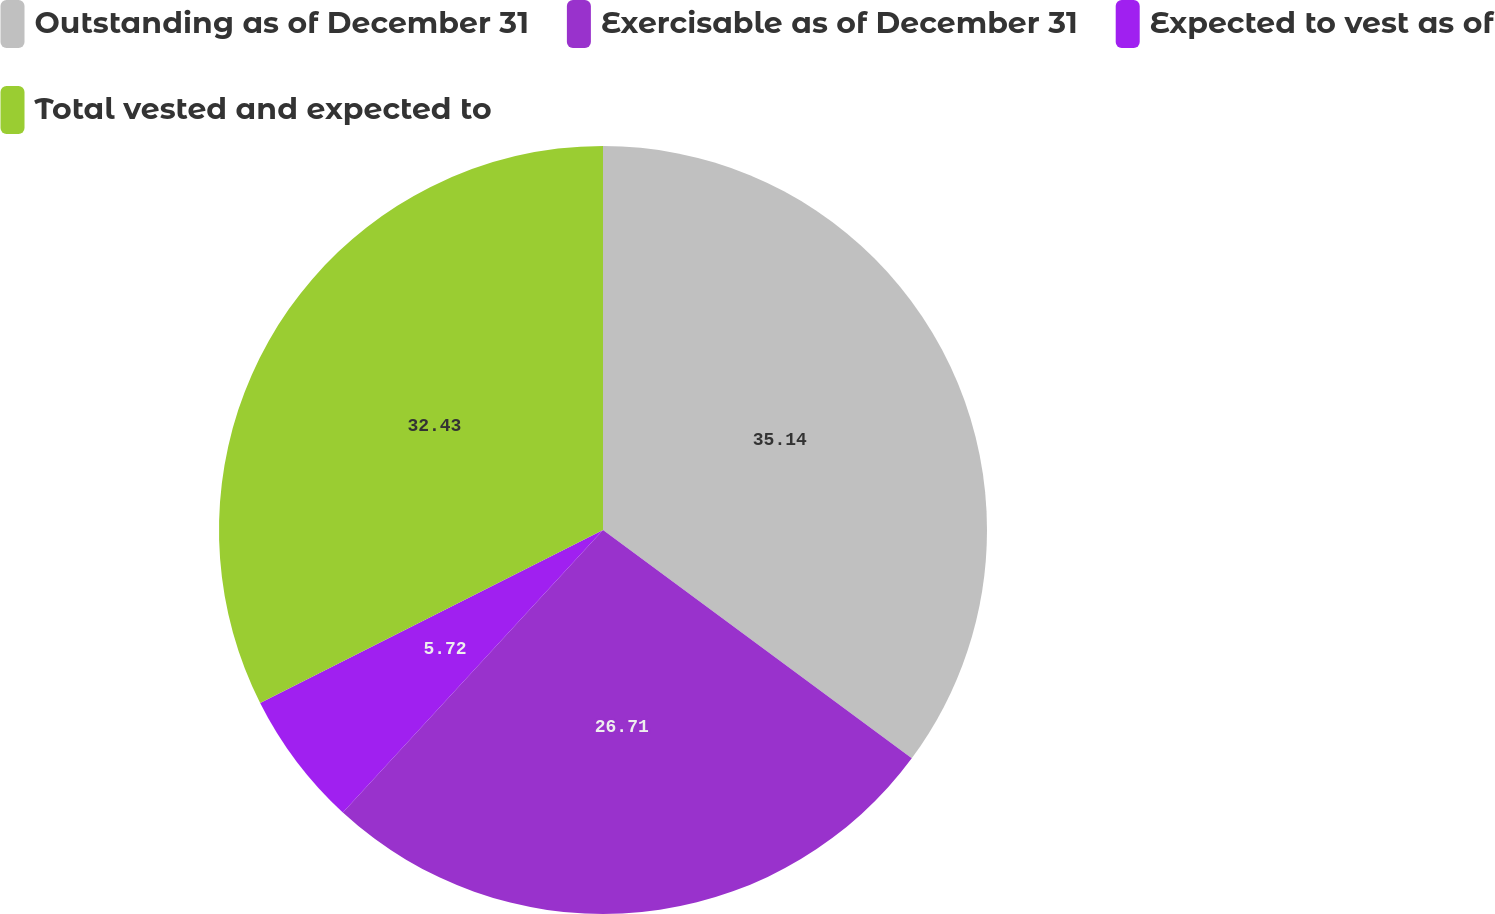Convert chart. <chart><loc_0><loc_0><loc_500><loc_500><pie_chart><fcel>Outstanding as of December 31<fcel>Exercisable as of December 31<fcel>Expected to vest as of<fcel>Total vested and expected to<nl><fcel>35.13%<fcel>26.71%<fcel>5.72%<fcel>32.43%<nl></chart> 